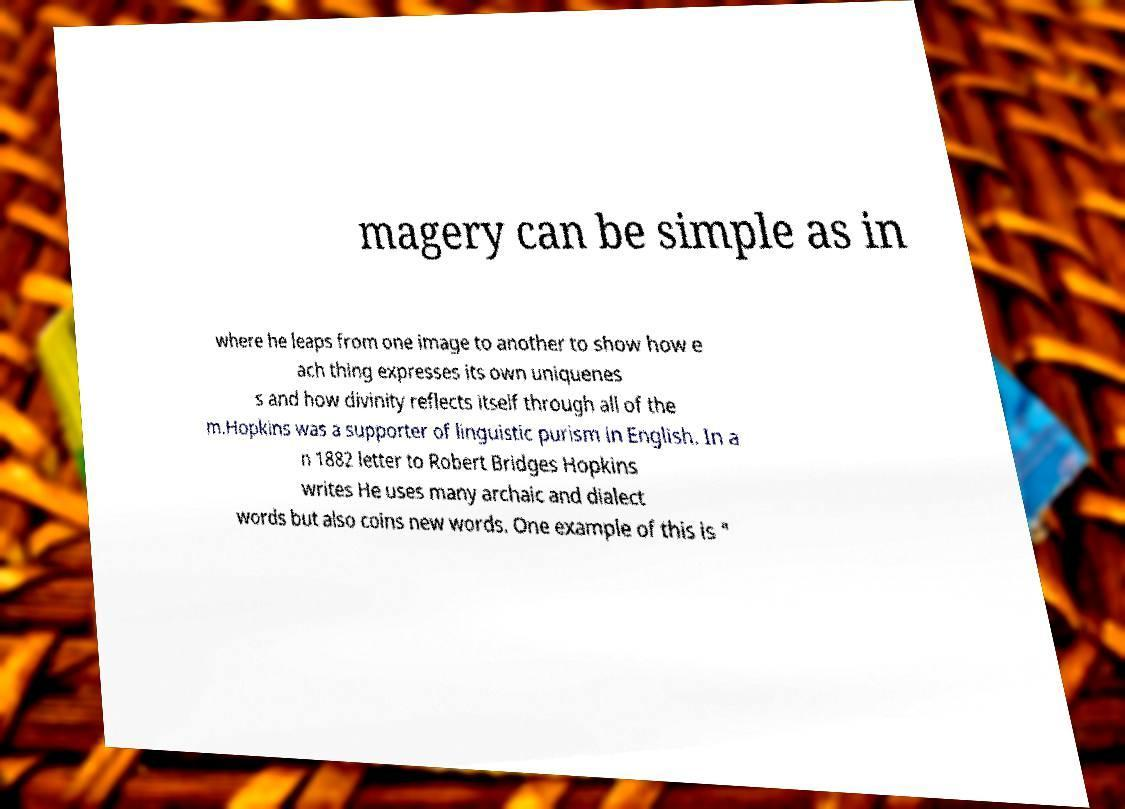For documentation purposes, I need the text within this image transcribed. Could you provide that? magery can be simple as in where he leaps from one image to another to show how e ach thing expresses its own uniquenes s and how divinity reflects itself through all of the m.Hopkins was a supporter of linguistic purism in English. In a n 1882 letter to Robert Bridges Hopkins writes He uses many archaic and dialect words but also coins new words. One example of this is " 